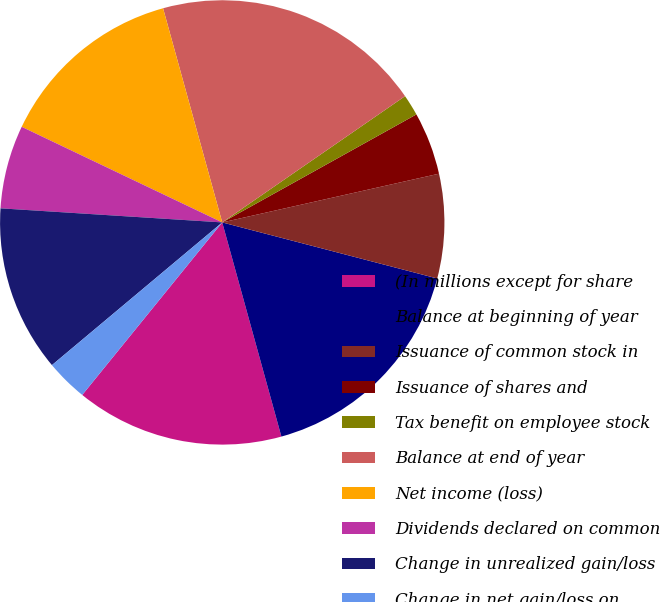Convert chart. <chart><loc_0><loc_0><loc_500><loc_500><pie_chart><fcel>(In millions except for share<fcel>Balance at beginning of year<fcel>Issuance of common stock in<fcel>Issuance of shares and<fcel>Tax benefit on employee stock<fcel>Balance at end of year<fcel>Net income (loss)<fcel>Dividends declared on common<fcel>Change in unrealized gain/loss<fcel>Change in net gain/loss on<nl><fcel>15.14%<fcel>16.65%<fcel>7.58%<fcel>4.56%<fcel>1.54%<fcel>19.67%<fcel>13.63%<fcel>6.07%<fcel>12.11%<fcel>3.05%<nl></chart> 